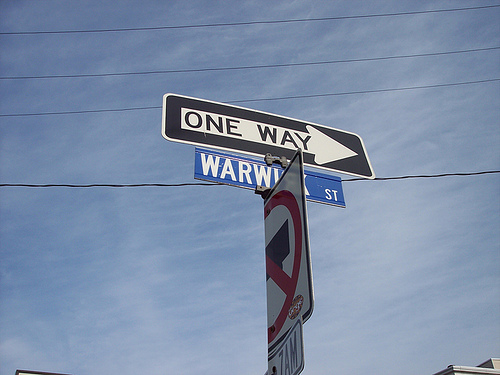Please identify all text content in this image. ONE WAY ST WARW 